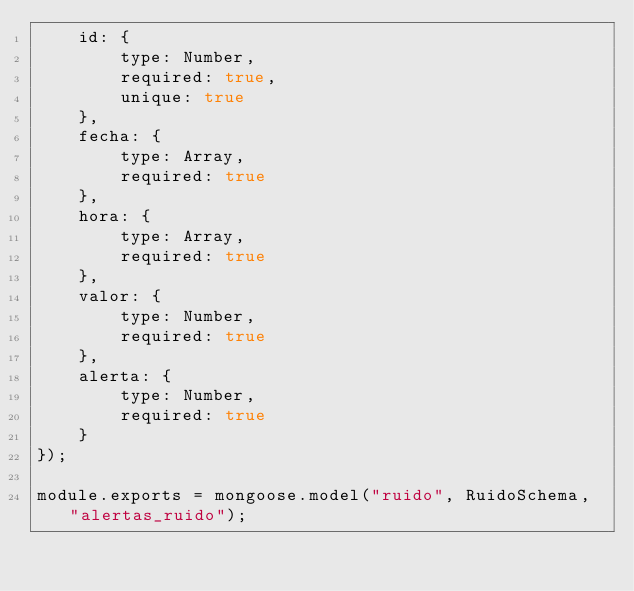<code> <loc_0><loc_0><loc_500><loc_500><_JavaScript_>    id: {
        type: Number,
        required: true,
        unique: true
    },
    fecha: {
        type: Array,
        required: true
    },
    hora: {
        type: Array,
        required: true
    },
    valor: {
        type: Number,
        required: true
    },
    alerta: {
        type: Number,
        required: true
    }
});

module.exports = mongoose.model("ruido", RuidoSchema, "alertas_ruido");</code> 